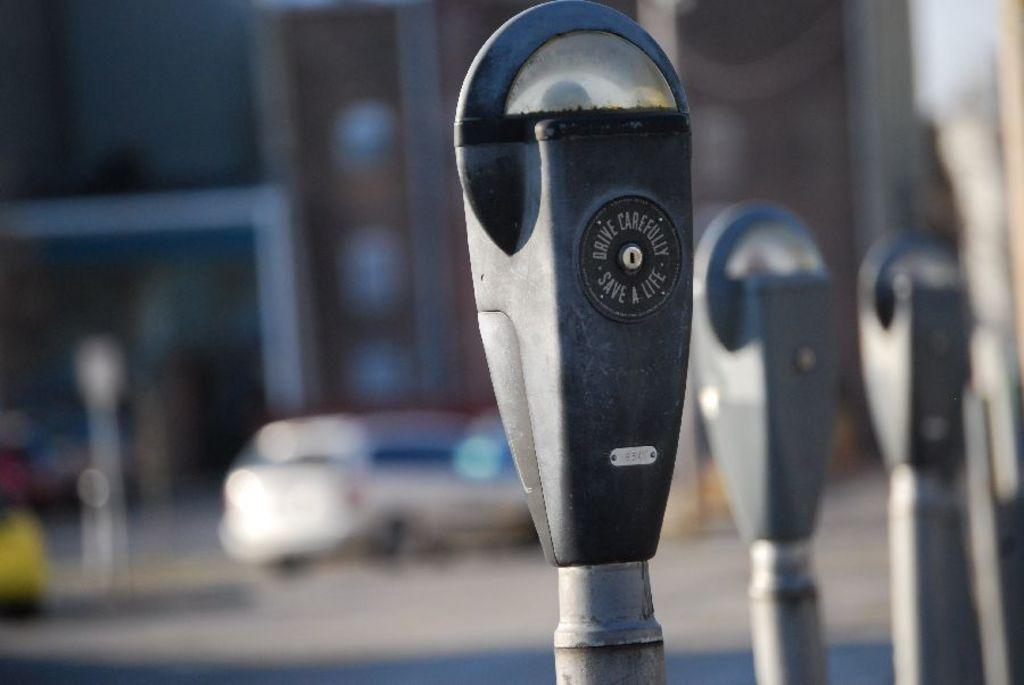Provide a one-sentence caption for the provided image. a parking meter outside with the word save on it. 